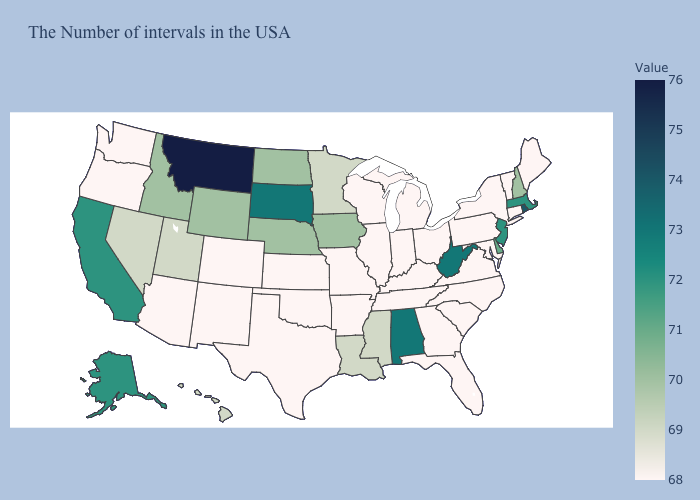Does Rhode Island have the highest value in the USA?
Write a very short answer. No. Among the states that border Arizona , does Colorado have the lowest value?
Answer briefly. Yes. Which states have the lowest value in the USA?
Write a very short answer. Maine, Vermont, Connecticut, New York, Maryland, Pennsylvania, Virginia, North Carolina, South Carolina, Ohio, Florida, Georgia, Michigan, Kentucky, Indiana, Tennessee, Wisconsin, Illinois, Missouri, Arkansas, Kansas, Oklahoma, Texas, Colorado, New Mexico, Arizona, Washington, Oregon. Does Ohio have the highest value in the MidWest?
Be succinct. No. Among the states that border Minnesota , does North Dakota have the highest value?
Be succinct. No. Among the states that border Idaho , which have the highest value?
Short answer required. Montana. 